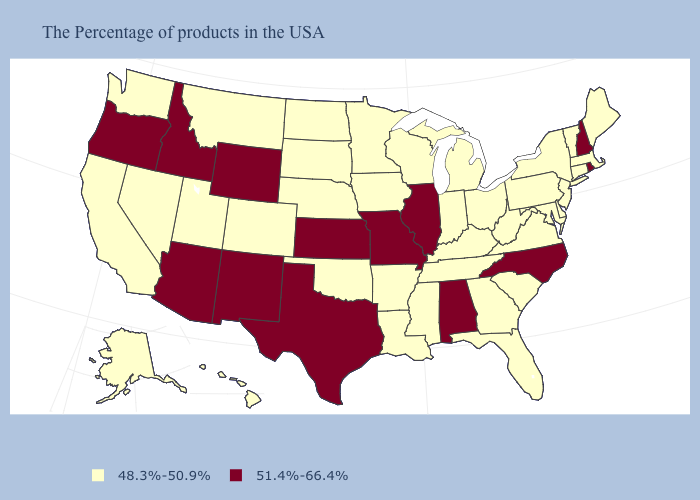What is the value of West Virginia?
Answer briefly. 48.3%-50.9%. What is the highest value in states that border New Hampshire?
Keep it brief. 48.3%-50.9%. Does Colorado have the highest value in the West?
Keep it brief. No. What is the value of Tennessee?
Be succinct. 48.3%-50.9%. Name the states that have a value in the range 51.4%-66.4%?
Write a very short answer. Rhode Island, New Hampshire, North Carolina, Alabama, Illinois, Missouri, Kansas, Texas, Wyoming, New Mexico, Arizona, Idaho, Oregon. What is the highest value in the USA?
Write a very short answer. 51.4%-66.4%. Which states hav the highest value in the South?
Give a very brief answer. North Carolina, Alabama, Texas. Name the states that have a value in the range 48.3%-50.9%?
Quick response, please. Maine, Massachusetts, Vermont, Connecticut, New York, New Jersey, Delaware, Maryland, Pennsylvania, Virginia, South Carolina, West Virginia, Ohio, Florida, Georgia, Michigan, Kentucky, Indiana, Tennessee, Wisconsin, Mississippi, Louisiana, Arkansas, Minnesota, Iowa, Nebraska, Oklahoma, South Dakota, North Dakota, Colorado, Utah, Montana, Nevada, California, Washington, Alaska, Hawaii. Name the states that have a value in the range 51.4%-66.4%?
Short answer required. Rhode Island, New Hampshire, North Carolina, Alabama, Illinois, Missouri, Kansas, Texas, Wyoming, New Mexico, Arizona, Idaho, Oregon. Among the states that border Indiana , which have the highest value?
Short answer required. Illinois. Name the states that have a value in the range 51.4%-66.4%?
Keep it brief. Rhode Island, New Hampshire, North Carolina, Alabama, Illinois, Missouri, Kansas, Texas, Wyoming, New Mexico, Arizona, Idaho, Oregon. What is the value of Massachusetts?
Concise answer only. 48.3%-50.9%. Name the states that have a value in the range 51.4%-66.4%?
Quick response, please. Rhode Island, New Hampshire, North Carolina, Alabama, Illinois, Missouri, Kansas, Texas, Wyoming, New Mexico, Arizona, Idaho, Oregon. Does Oregon have the lowest value in the USA?
Quick response, please. No. 